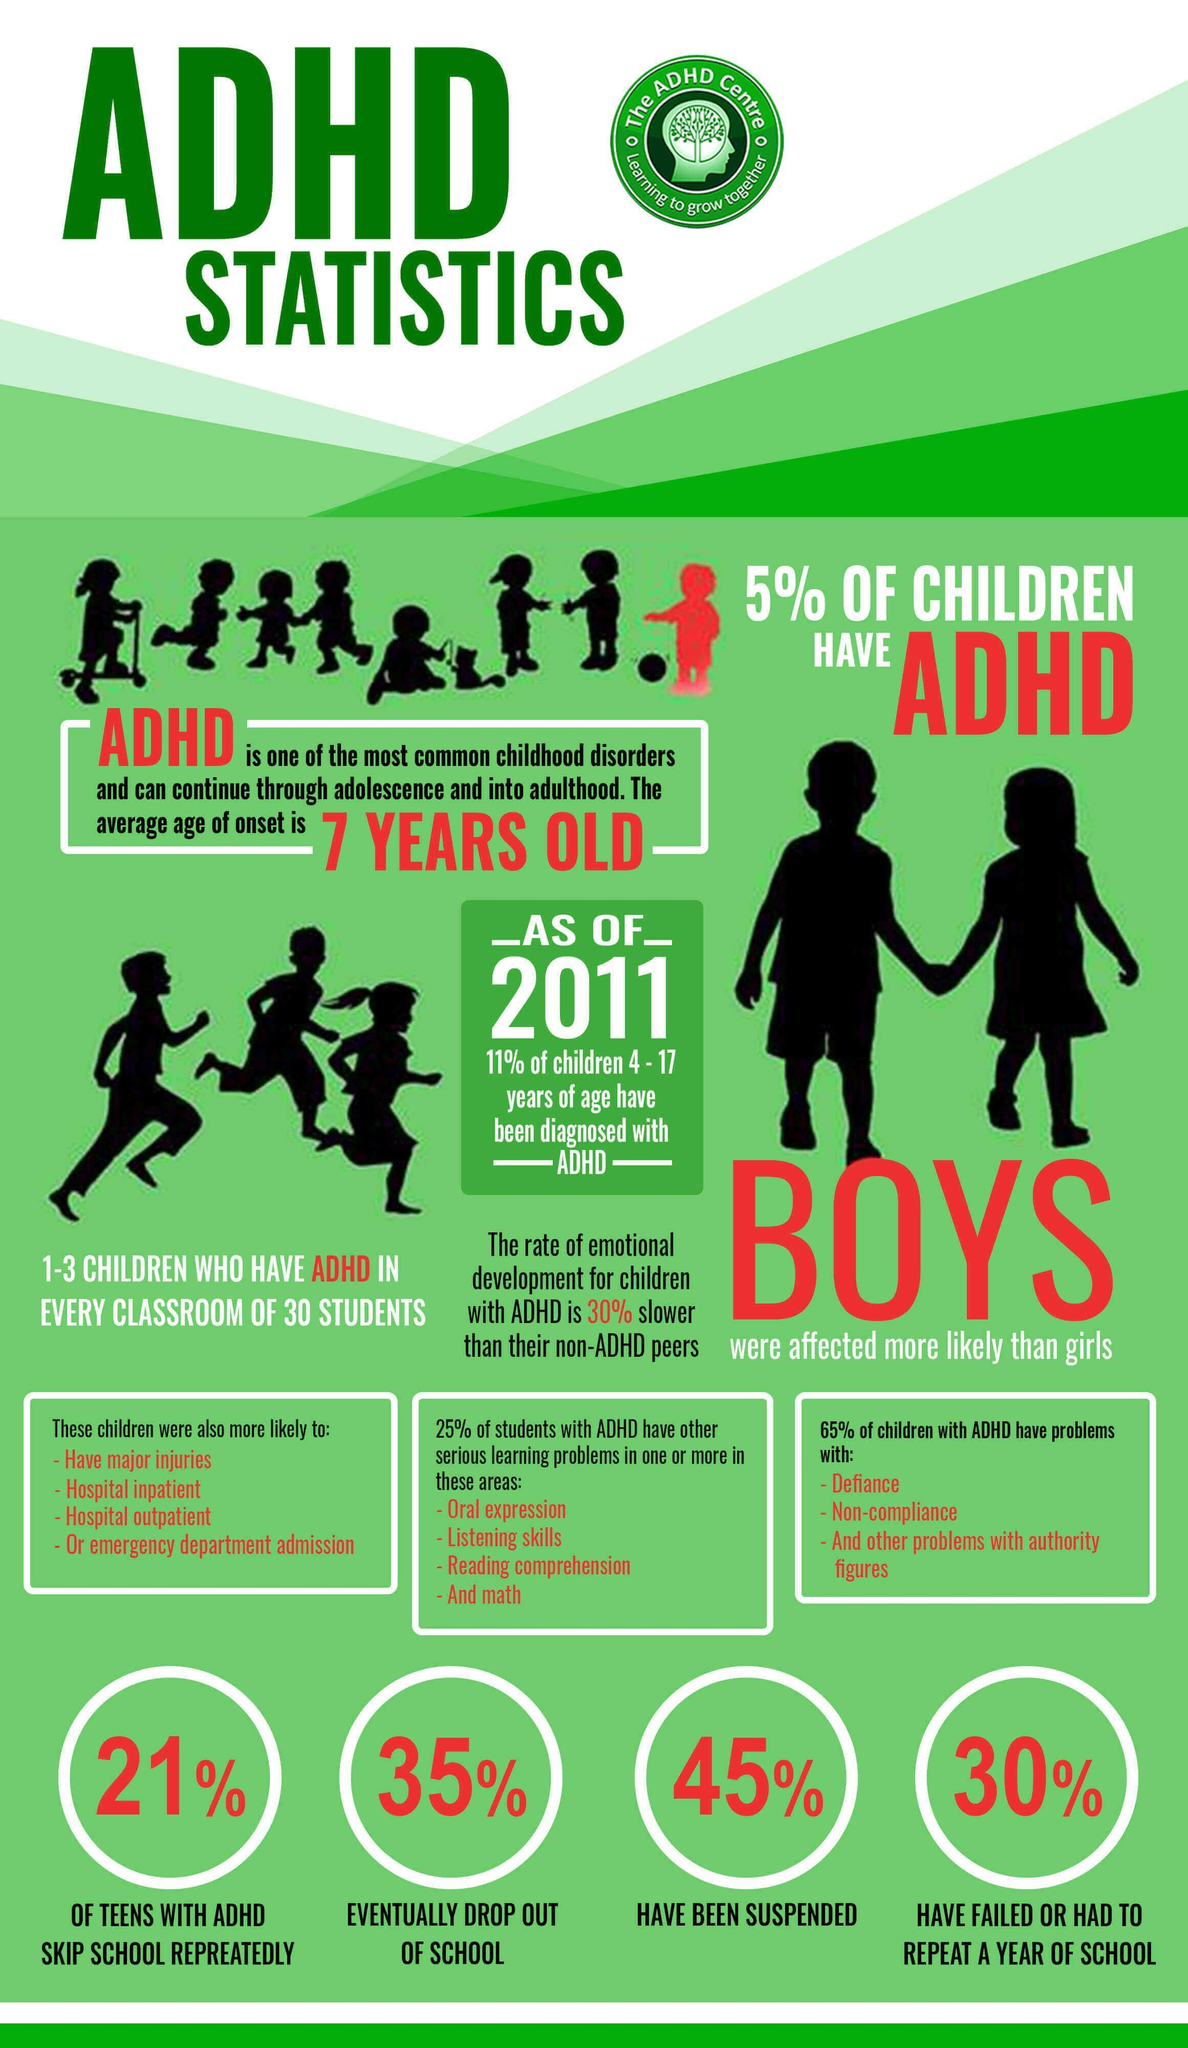In a classroom of 30 students, how many are expected to have ADHD?
Answer the question with a short phrase. 1-3 children What is the percentage of children with ADHD who have not been suspended? 55% In what color the heading is written - white, red, or green? green How many silhouettes of children are given just above the big red text "BOYS"? 2 How many circles are given at the bottom graphics? 4 What is the total count of the text "ADHD" in this infographic? 10 Who is less likely to be affected - boys or girls? girls How is emotional development of children diagnosed with ADHD is different from that of normal child? the rate of emotional development for children with ADHD is 30% slower than their non-ADHD peers How many white rectangles are there just above the four circles? 3 